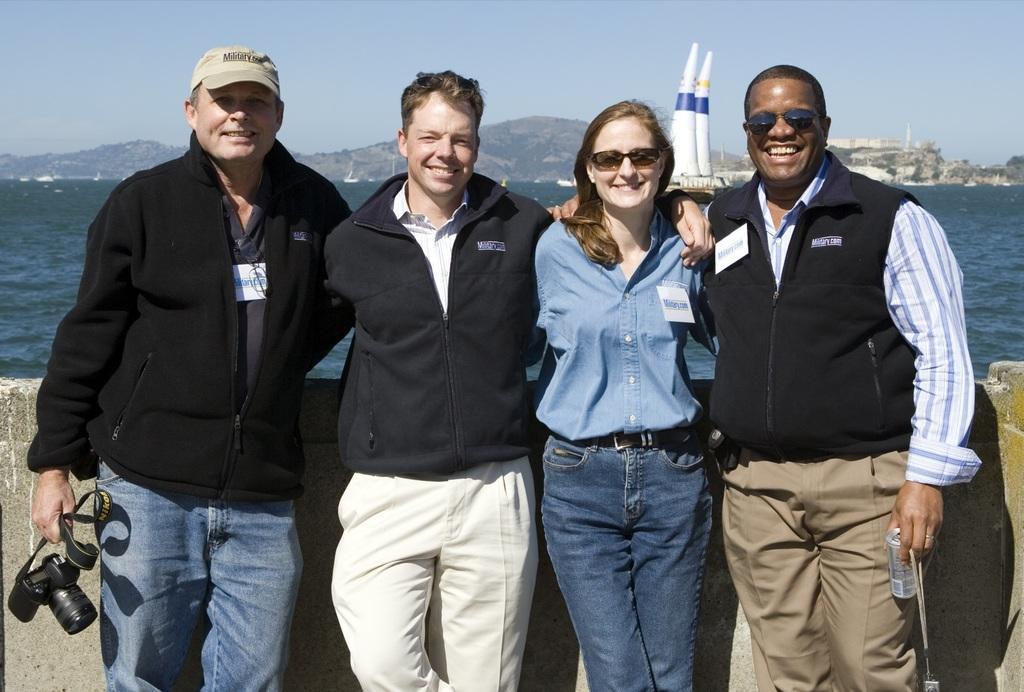Describe this image in one or two sentences. The image there are four people three men and a woman,four of them are smiling and posing for the photo. The left side last person is holding a camera with his hand and behind these people there is a sea and behind the sea there are some mountains. 